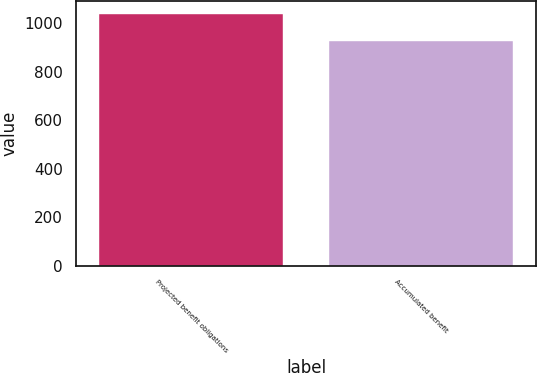Convert chart to OTSL. <chart><loc_0><loc_0><loc_500><loc_500><bar_chart><fcel>Projected benefit obligations<fcel>Accumulated benefit<nl><fcel>1037<fcel>927<nl></chart> 